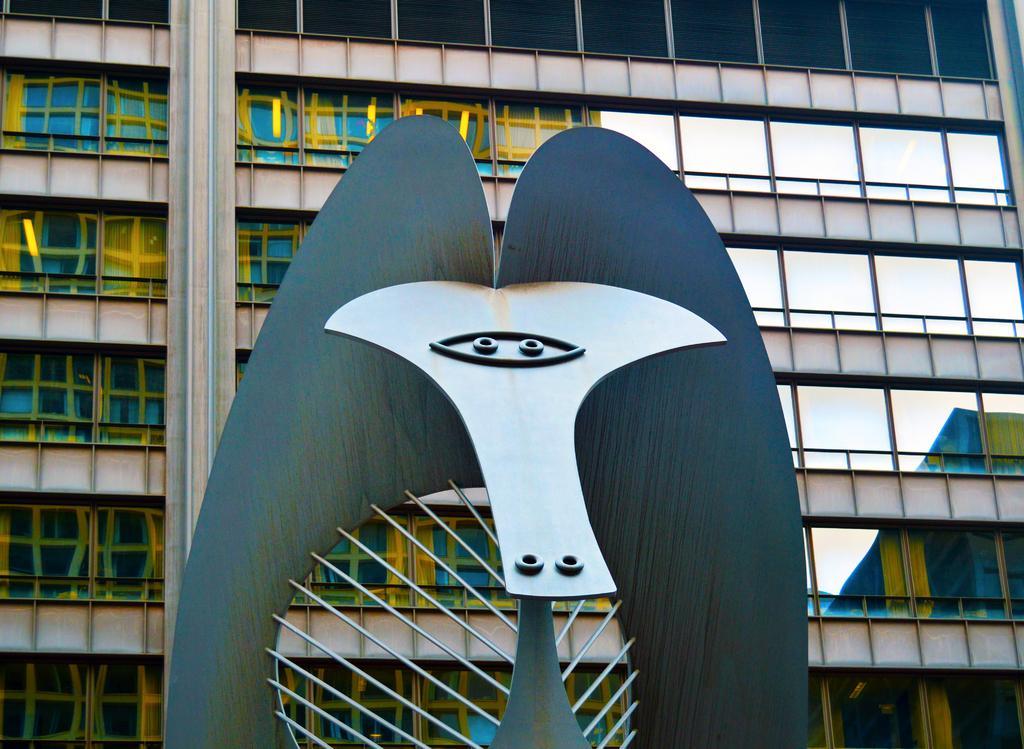Can you describe this image briefly? Here in this picture in the front we can see an architectural thing present over there and behind that we can see a building, which is fully covered with glass. 